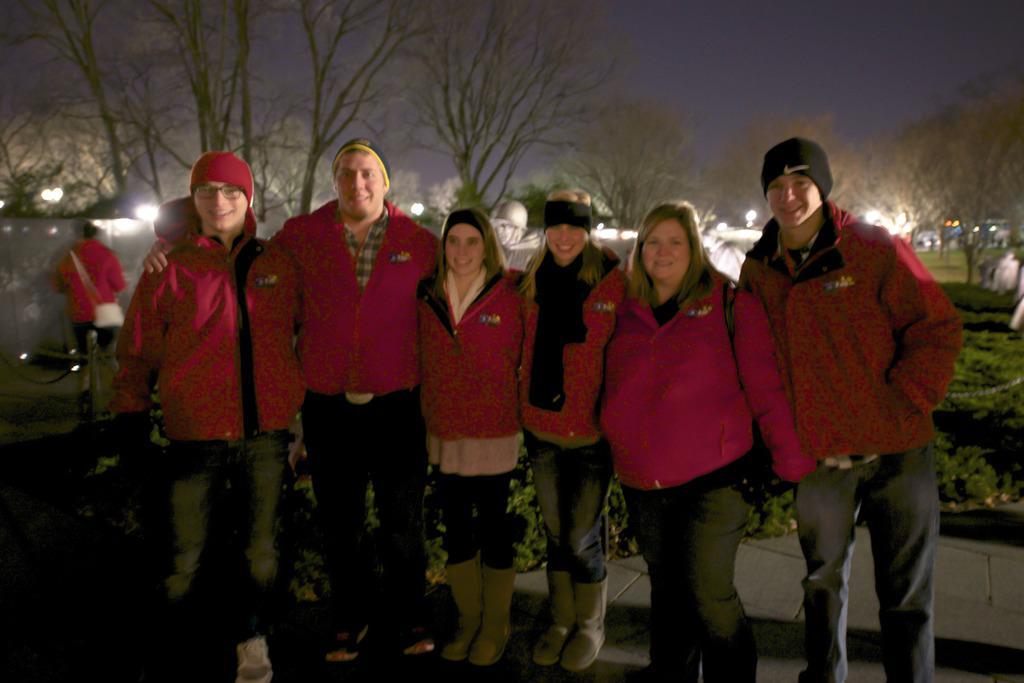Could you give a brief overview of what you see in this image? In this picture I can observe six members standing in the middle of the picture. There are men and women in this picture. All of them are smiling. In the background I can observe trees and sky. 